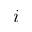<formula> <loc_0><loc_0><loc_500><loc_500>i</formula> 